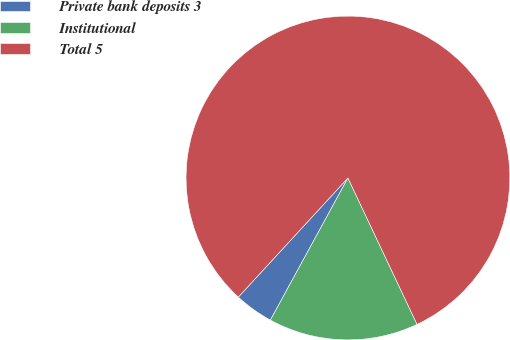Convert chart to OTSL. <chart><loc_0><loc_0><loc_500><loc_500><pie_chart><fcel>Private bank deposits 3<fcel>Institutional<fcel>Total 5<nl><fcel>3.89%<fcel>14.97%<fcel>81.14%<nl></chart> 